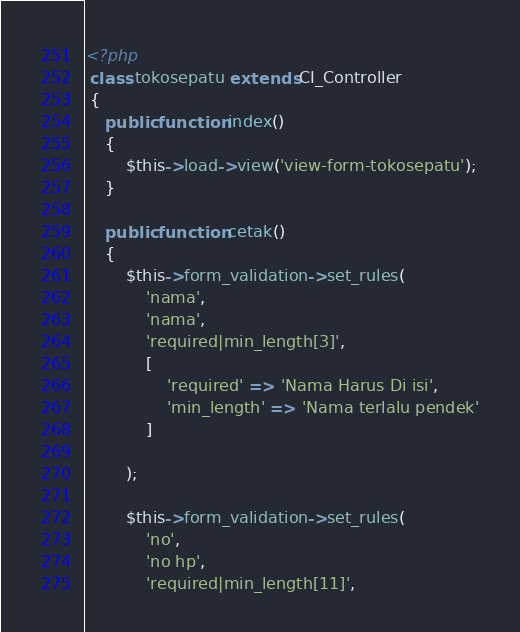<code> <loc_0><loc_0><loc_500><loc_500><_PHP_><?php
 class tokosepatu extends CI_Controller
 {
    public function index()
    {
        $this->load->view('view-form-tokosepatu');
    }

    public function cetak()
    {
        $this->form_validation->set_rules(
            'nama',
            'nama',
            'required|min_length[3]',
            [
                'required' => 'Nama Harus Di isi',
                'min_length' => 'Nama terlalu pendek'
            ]
        
        );
        
        $this->form_validation->set_rules(
            'no',
            'no hp',
            'required|min_length[11]',</code> 